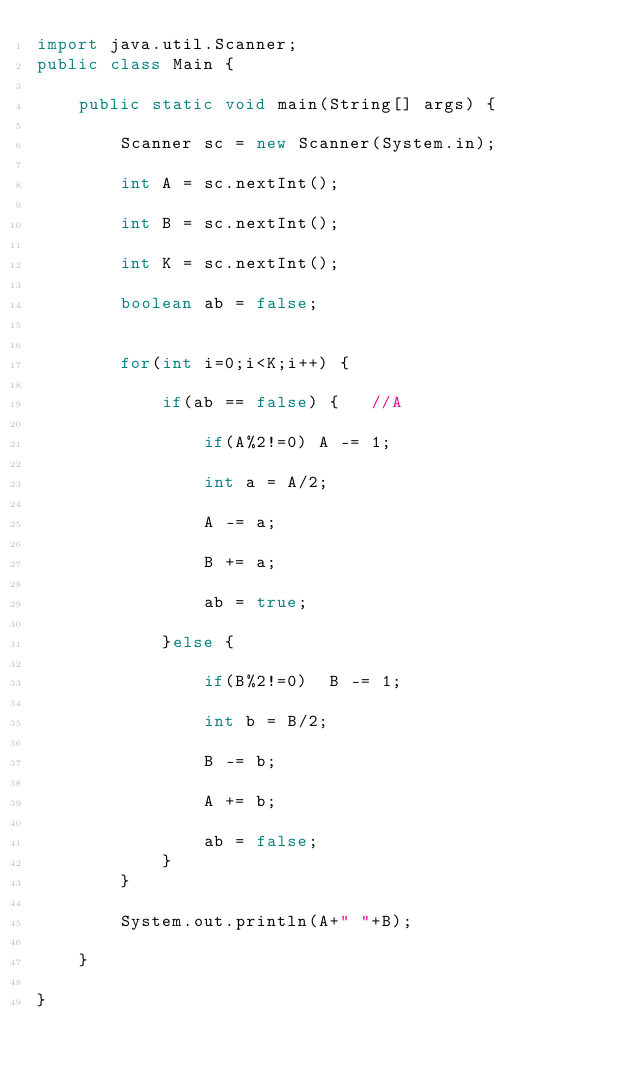Convert code to text. <code><loc_0><loc_0><loc_500><loc_500><_Java_>import java.util.Scanner;
public class Main {

	public static void main(String[] args) {

		Scanner sc = new Scanner(System.in);

		int A = sc.nextInt();

		int B = sc.nextInt();

		int K = sc.nextInt();

		boolean ab = false;


		for(int i=0;i<K;i++) {

			if(ab == false) {	//A

				if(A%2!=0) A -= 1;

				int a = A/2;

				A -= a;

				B += a;

				ab = true;

			}else {

				if(B%2!=0)  B -= 1;

				int b = B/2;

				B -= b;

				A += b;

				ab = false;
			}
		}

		System.out.println(A+" "+B);

	}

}
</code> 